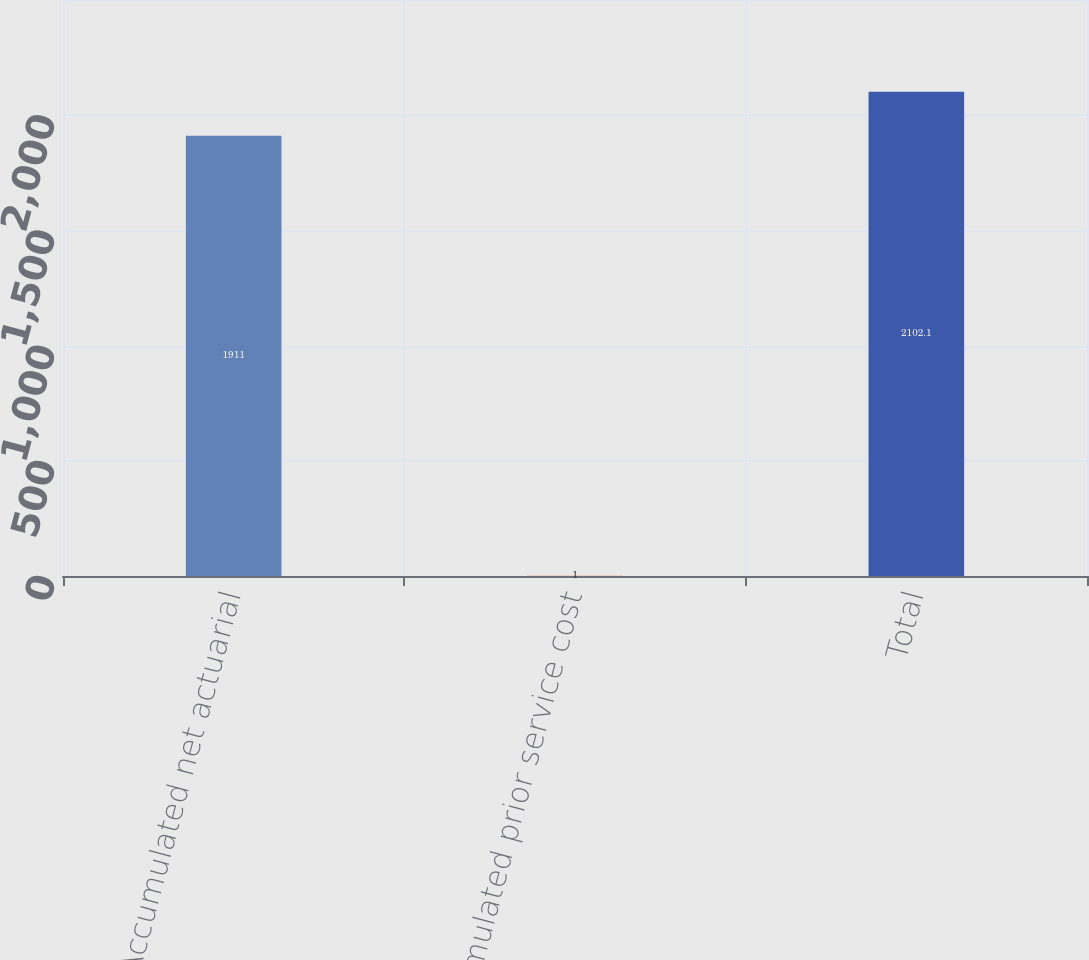<chart> <loc_0><loc_0><loc_500><loc_500><bar_chart><fcel>Accumulated net actuarial<fcel>Accumulated prior service cost<fcel>Total<nl><fcel>1911<fcel>1<fcel>2102.1<nl></chart> 